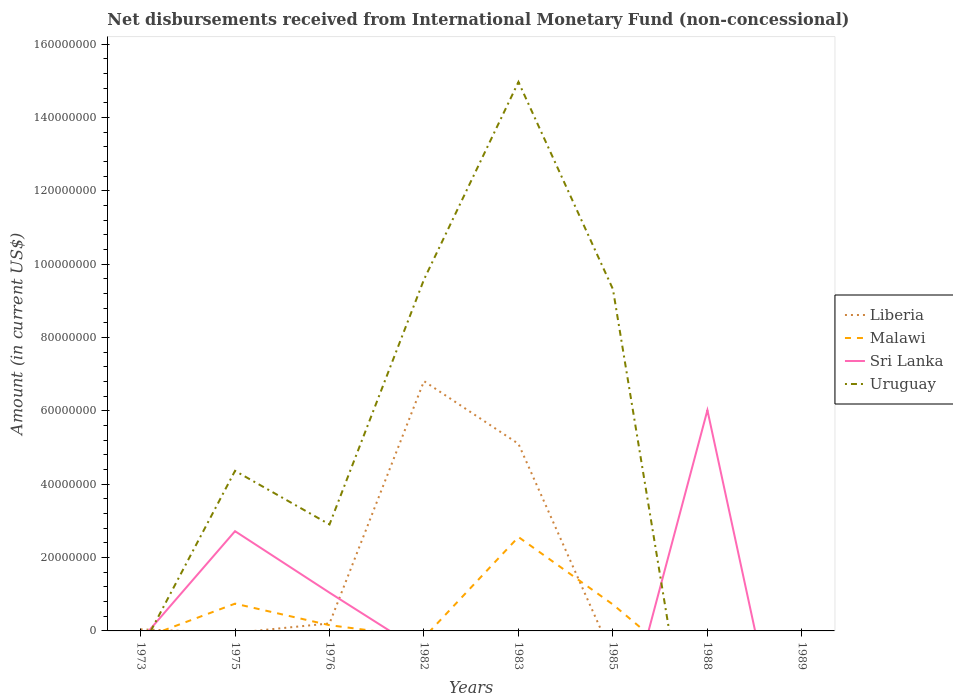Does the line corresponding to Uruguay intersect with the line corresponding to Malawi?
Your answer should be compact. Yes. Across all years, what is the maximum amount of disbursements received from International Monetary Fund in Sri Lanka?
Your response must be concise. 0. What is the total amount of disbursements received from International Monetary Fund in Liberia in the graph?
Ensure brevity in your answer.  -6.77e+07. What is the difference between the highest and the second highest amount of disbursements received from International Monetary Fund in Liberia?
Ensure brevity in your answer.  6.81e+07. What is the difference between the highest and the lowest amount of disbursements received from International Monetary Fund in Uruguay?
Offer a very short reply. 3. How many years are there in the graph?
Offer a very short reply. 8. What is the difference between two consecutive major ticks on the Y-axis?
Make the answer very short. 2.00e+07. Does the graph contain any zero values?
Ensure brevity in your answer.  Yes. Where does the legend appear in the graph?
Ensure brevity in your answer.  Center right. How are the legend labels stacked?
Keep it short and to the point. Vertical. What is the title of the graph?
Your answer should be very brief. Net disbursements received from International Monetary Fund (non-concessional). What is the Amount (in current US$) of Liberia in 1973?
Keep it short and to the point. 4.29e+05. What is the Amount (in current US$) of Malawi in 1973?
Offer a terse response. 0. What is the Amount (in current US$) of Sri Lanka in 1973?
Provide a succinct answer. 0. What is the Amount (in current US$) in Malawi in 1975?
Provide a short and direct response. 7.43e+06. What is the Amount (in current US$) in Sri Lanka in 1975?
Offer a terse response. 2.72e+07. What is the Amount (in current US$) of Uruguay in 1975?
Give a very brief answer. 4.36e+07. What is the Amount (in current US$) in Liberia in 1976?
Offer a very short reply. 2.04e+06. What is the Amount (in current US$) in Malawi in 1976?
Your answer should be very brief. 1.57e+06. What is the Amount (in current US$) of Sri Lanka in 1976?
Give a very brief answer. 1.04e+07. What is the Amount (in current US$) in Uruguay in 1976?
Your answer should be compact. 2.90e+07. What is the Amount (in current US$) in Liberia in 1982?
Your answer should be compact. 6.81e+07. What is the Amount (in current US$) in Malawi in 1982?
Offer a terse response. 0. What is the Amount (in current US$) in Sri Lanka in 1982?
Make the answer very short. 0. What is the Amount (in current US$) of Uruguay in 1982?
Your response must be concise. 9.58e+07. What is the Amount (in current US$) in Liberia in 1983?
Offer a terse response. 5.10e+07. What is the Amount (in current US$) of Malawi in 1983?
Make the answer very short. 2.56e+07. What is the Amount (in current US$) of Uruguay in 1983?
Provide a short and direct response. 1.50e+08. What is the Amount (in current US$) of Liberia in 1985?
Offer a terse response. 0. What is the Amount (in current US$) in Malawi in 1985?
Offer a terse response. 7.20e+06. What is the Amount (in current US$) in Uruguay in 1985?
Your response must be concise. 9.32e+07. What is the Amount (in current US$) in Liberia in 1988?
Give a very brief answer. 0. What is the Amount (in current US$) of Sri Lanka in 1988?
Make the answer very short. 6.02e+07. What is the Amount (in current US$) in Liberia in 1989?
Your response must be concise. 0. What is the Amount (in current US$) in Uruguay in 1989?
Your answer should be compact. 0. Across all years, what is the maximum Amount (in current US$) in Liberia?
Your response must be concise. 6.81e+07. Across all years, what is the maximum Amount (in current US$) of Malawi?
Provide a short and direct response. 2.56e+07. Across all years, what is the maximum Amount (in current US$) in Sri Lanka?
Make the answer very short. 6.02e+07. Across all years, what is the maximum Amount (in current US$) of Uruguay?
Your answer should be very brief. 1.50e+08. Across all years, what is the minimum Amount (in current US$) of Malawi?
Provide a short and direct response. 0. What is the total Amount (in current US$) of Liberia in the graph?
Keep it short and to the point. 1.22e+08. What is the total Amount (in current US$) of Malawi in the graph?
Your response must be concise. 4.18e+07. What is the total Amount (in current US$) in Sri Lanka in the graph?
Offer a terse response. 9.78e+07. What is the total Amount (in current US$) of Uruguay in the graph?
Your answer should be very brief. 4.11e+08. What is the difference between the Amount (in current US$) in Liberia in 1973 and that in 1976?
Your answer should be compact. -1.62e+06. What is the difference between the Amount (in current US$) in Liberia in 1973 and that in 1982?
Your response must be concise. -6.77e+07. What is the difference between the Amount (in current US$) of Liberia in 1973 and that in 1983?
Make the answer very short. -5.06e+07. What is the difference between the Amount (in current US$) in Malawi in 1975 and that in 1976?
Give a very brief answer. 5.86e+06. What is the difference between the Amount (in current US$) in Sri Lanka in 1975 and that in 1976?
Keep it short and to the point. 1.68e+07. What is the difference between the Amount (in current US$) in Uruguay in 1975 and that in 1976?
Your answer should be compact. 1.46e+07. What is the difference between the Amount (in current US$) in Uruguay in 1975 and that in 1982?
Give a very brief answer. -5.22e+07. What is the difference between the Amount (in current US$) of Malawi in 1975 and that in 1983?
Your answer should be very brief. -1.82e+07. What is the difference between the Amount (in current US$) of Uruguay in 1975 and that in 1983?
Ensure brevity in your answer.  -1.06e+08. What is the difference between the Amount (in current US$) in Malawi in 1975 and that in 1985?
Your answer should be very brief. 2.33e+05. What is the difference between the Amount (in current US$) of Uruguay in 1975 and that in 1985?
Make the answer very short. -4.95e+07. What is the difference between the Amount (in current US$) in Sri Lanka in 1975 and that in 1988?
Provide a succinct answer. -3.30e+07. What is the difference between the Amount (in current US$) in Liberia in 1976 and that in 1982?
Your answer should be compact. -6.61e+07. What is the difference between the Amount (in current US$) in Uruguay in 1976 and that in 1982?
Your response must be concise. -6.68e+07. What is the difference between the Amount (in current US$) of Liberia in 1976 and that in 1983?
Offer a terse response. -4.90e+07. What is the difference between the Amount (in current US$) of Malawi in 1976 and that in 1983?
Provide a succinct answer. -2.40e+07. What is the difference between the Amount (in current US$) in Uruguay in 1976 and that in 1983?
Provide a short and direct response. -1.21e+08. What is the difference between the Amount (in current US$) in Malawi in 1976 and that in 1985?
Your answer should be compact. -5.63e+06. What is the difference between the Amount (in current US$) of Uruguay in 1976 and that in 1985?
Provide a short and direct response. -6.41e+07. What is the difference between the Amount (in current US$) of Sri Lanka in 1976 and that in 1988?
Offer a very short reply. -4.97e+07. What is the difference between the Amount (in current US$) of Liberia in 1982 and that in 1983?
Offer a terse response. 1.71e+07. What is the difference between the Amount (in current US$) of Uruguay in 1982 and that in 1983?
Give a very brief answer. -5.39e+07. What is the difference between the Amount (in current US$) of Uruguay in 1982 and that in 1985?
Your answer should be compact. 2.64e+06. What is the difference between the Amount (in current US$) in Malawi in 1983 and that in 1985?
Provide a short and direct response. 1.84e+07. What is the difference between the Amount (in current US$) of Uruguay in 1983 and that in 1985?
Provide a short and direct response. 5.65e+07. What is the difference between the Amount (in current US$) in Liberia in 1973 and the Amount (in current US$) in Malawi in 1975?
Your answer should be compact. -7.00e+06. What is the difference between the Amount (in current US$) in Liberia in 1973 and the Amount (in current US$) in Sri Lanka in 1975?
Give a very brief answer. -2.68e+07. What is the difference between the Amount (in current US$) in Liberia in 1973 and the Amount (in current US$) in Uruguay in 1975?
Ensure brevity in your answer.  -4.32e+07. What is the difference between the Amount (in current US$) in Liberia in 1973 and the Amount (in current US$) in Malawi in 1976?
Give a very brief answer. -1.14e+06. What is the difference between the Amount (in current US$) in Liberia in 1973 and the Amount (in current US$) in Sri Lanka in 1976?
Provide a short and direct response. -1.00e+07. What is the difference between the Amount (in current US$) in Liberia in 1973 and the Amount (in current US$) in Uruguay in 1976?
Offer a terse response. -2.86e+07. What is the difference between the Amount (in current US$) in Liberia in 1973 and the Amount (in current US$) in Uruguay in 1982?
Ensure brevity in your answer.  -9.54e+07. What is the difference between the Amount (in current US$) in Liberia in 1973 and the Amount (in current US$) in Malawi in 1983?
Offer a very short reply. -2.52e+07. What is the difference between the Amount (in current US$) in Liberia in 1973 and the Amount (in current US$) in Uruguay in 1983?
Provide a succinct answer. -1.49e+08. What is the difference between the Amount (in current US$) in Liberia in 1973 and the Amount (in current US$) in Malawi in 1985?
Offer a terse response. -6.77e+06. What is the difference between the Amount (in current US$) of Liberia in 1973 and the Amount (in current US$) of Uruguay in 1985?
Provide a succinct answer. -9.27e+07. What is the difference between the Amount (in current US$) of Liberia in 1973 and the Amount (in current US$) of Sri Lanka in 1988?
Give a very brief answer. -5.97e+07. What is the difference between the Amount (in current US$) of Malawi in 1975 and the Amount (in current US$) of Sri Lanka in 1976?
Your answer should be compact. -3.00e+06. What is the difference between the Amount (in current US$) of Malawi in 1975 and the Amount (in current US$) of Uruguay in 1976?
Your answer should be very brief. -2.16e+07. What is the difference between the Amount (in current US$) in Sri Lanka in 1975 and the Amount (in current US$) in Uruguay in 1976?
Ensure brevity in your answer.  -1.83e+06. What is the difference between the Amount (in current US$) in Malawi in 1975 and the Amount (in current US$) in Uruguay in 1982?
Give a very brief answer. -8.84e+07. What is the difference between the Amount (in current US$) in Sri Lanka in 1975 and the Amount (in current US$) in Uruguay in 1982?
Give a very brief answer. -6.86e+07. What is the difference between the Amount (in current US$) of Malawi in 1975 and the Amount (in current US$) of Uruguay in 1983?
Ensure brevity in your answer.  -1.42e+08. What is the difference between the Amount (in current US$) in Sri Lanka in 1975 and the Amount (in current US$) in Uruguay in 1983?
Give a very brief answer. -1.22e+08. What is the difference between the Amount (in current US$) in Malawi in 1975 and the Amount (in current US$) in Uruguay in 1985?
Your response must be concise. -8.57e+07. What is the difference between the Amount (in current US$) in Sri Lanka in 1975 and the Amount (in current US$) in Uruguay in 1985?
Your answer should be compact. -6.60e+07. What is the difference between the Amount (in current US$) in Malawi in 1975 and the Amount (in current US$) in Sri Lanka in 1988?
Give a very brief answer. -5.27e+07. What is the difference between the Amount (in current US$) of Liberia in 1976 and the Amount (in current US$) of Uruguay in 1982?
Provide a short and direct response. -9.38e+07. What is the difference between the Amount (in current US$) in Malawi in 1976 and the Amount (in current US$) in Uruguay in 1982?
Make the answer very short. -9.42e+07. What is the difference between the Amount (in current US$) of Sri Lanka in 1976 and the Amount (in current US$) of Uruguay in 1982?
Provide a succinct answer. -8.54e+07. What is the difference between the Amount (in current US$) in Liberia in 1976 and the Amount (in current US$) in Malawi in 1983?
Offer a very short reply. -2.36e+07. What is the difference between the Amount (in current US$) of Liberia in 1976 and the Amount (in current US$) of Uruguay in 1983?
Provide a short and direct response. -1.48e+08. What is the difference between the Amount (in current US$) of Malawi in 1976 and the Amount (in current US$) of Uruguay in 1983?
Your answer should be compact. -1.48e+08. What is the difference between the Amount (in current US$) of Sri Lanka in 1976 and the Amount (in current US$) of Uruguay in 1983?
Ensure brevity in your answer.  -1.39e+08. What is the difference between the Amount (in current US$) of Liberia in 1976 and the Amount (in current US$) of Malawi in 1985?
Give a very brief answer. -5.16e+06. What is the difference between the Amount (in current US$) of Liberia in 1976 and the Amount (in current US$) of Uruguay in 1985?
Give a very brief answer. -9.11e+07. What is the difference between the Amount (in current US$) in Malawi in 1976 and the Amount (in current US$) in Uruguay in 1985?
Provide a short and direct response. -9.16e+07. What is the difference between the Amount (in current US$) in Sri Lanka in 1976 and the Amount (in current US$) in Uruguay in 1985?
Provide a short and direct response. -8.27e+07. What is the difference between the Amount (in current US$) in Liberia in 1976 and the Amount (in current US$) in Sri Lanka in 1988?
Your answer should be compact. -5.81e+07. What is the difference between the Amount (in current US$) in Malawi in 1976 and the Amount (in current US$) in Sri Lanka in 1988?
Keep it short and to the point. -5.86e+07. What is the difference between the Amount (in current US$) of Liberia in 1982 and the Amount (in current US$) of Malawi in 1983?
Provide a short and direct response. 4.25e+07. What is the difference between the Amount (in current US$) in Liberia in 1982 and the Amount (in current US$) in Uruguay in 1983?
Offer a terse response. -8.16e+07. What is the difference between the Amount (in current US$) of Liberia in 1982 and the Amount (in current US$) of Malawi in 1985?
Provide a short and direct response. 6.09e+07. What is the difference between the Amount (in current US$) in Liberia in 1982 and the Amount (in current US$) in Uruguay in 1985?
Give a very brief answer. -2.51e+07. What is the difference between the Amount (in current US$) of Liberia in 1982 and the Amount (in current US$) of Sri Lanka in 1988?
Offer a terse response. 7.93e+06. What is the difference between the Amount (in current US$) in Liberia in 1983 and the Amount (in current US$) in Malawi in 1985?
Offer a very short reply. 4.38e+07. What is the difference between the Amount (in current US$) of Liberia in 1983 and the Amount (in current US$) of Uruguay in 1985?
Provide a short and direct response. -4.22e+07. What is the difference between the Amount (in current US$) of Malawi in 1983 and the Amount (in current US$) of Uruguay in 1985?
Offer a terse response. -6.76e+07. What is the difference between the Amount (in current US$) of Liberia in 1983 and the Amount (in current US$) of Sri Lanka in 1988?
Provide a short and direct response. -9.17e+06. What is the difference between the Amount (in current US$) in Malawi in 1983 and the Amount (in current US$) in Sri Lanka in 1988?
Ensure brevity in your answer.  -3.46e+07. What is the difference between the Amount (in current US$) of Malawi in 1985 and the Amount (in current US$) of Sri Lanka in 1988?
Offer a very short reply. -5.30e+07. What is the average Amount (in current US$) of Liberia per year?
Make the answer very short. 1.52e+07. What is the average Amount (in current US$) of Malawi per year?
Your response must be concise. 5.23e+06. What is the average Amount (in current US$) in Sri Lanka per year?
Provide a succinct answer. 1.22e+07. What is the average Amount (in current US$) in Uruguay per year?
Give a very brief answer. 5.14e+07. In the year 1975, what is the difference between the Amount (in current US$) in Malawi and Amount (in current US$) in Sri Lanka?
Make the answer very short. -1.98e+07. In the year 1975, what is the difference between the Amount (in current US$) of Malawi and Amount (in current US$) of Uruguay?
Offer a very short reply. -3.62e+07. In the year 1975, what is the difference between the Amount (in current US$) in Sri Lanka and Amount (in current US$) in Uruguay?
Your answer should be very brief. -1.64e+07. In the year 1976, what is the difference between the Amount (in current US$) of Liberia and Amount (in current US$) of Malawi?
Ensure brevity in your answer.  4.74e+05. In the year 1976, what is the difference between the Amount (in current US$) in Liberia and Amount (in current US$) in Sri Lanka?
Give a very brief answer. -8.39e+06. In the year 1976, what is the difference between the Amount (in current US$) of Liberia and Amount (in current US$) of Uruguay?
Give a very brief answer. -2.70e+07. In the year 1976, what is the difference between the Amount (in current US$) in Malawi and Amount (in current US$) in Sri Lanka?
Your answer should be very brief. -8.86e+06. In the year 1976, what is the difference between the Amount (in current US$) in Malawi and Amount (in current US$) in Uruguay?
Provide a succinct answer. -2.75e+07. In the year 1976, what is the difference between the Amount (in current US$) in Sri Lanka and Amount (in current US$) in Uruguay?
Keep it short and to the point. -1.86e+07. In the year 1982, what is the difference between the Amount (in current US$) in Liberia and Amount (in current US$) in Uruguay?
Your answer should be very brief. -2.77e+07. In the year 1983, what is the difference between the Amount (in current US$) of Liberia and Amount (in current US$) of Malawi?
Make the answer very short. 2.54e+07. In the year 1983, what is the difference between the Amount (in current US$) in Liberia and Amount (in current US$) in Uruguay?
Keep it short and to the point. -9.87e+07. In the year 1983, what is the difference between the Amount (in current US$) in Malawi and Amount (in current US$) in Uruguay?
Give a very brief answer. -1.24e+08. In the year 1985, what is the difference between the Amount (in current US$) in Malawi and Amount (in current US$) in Uruguay?
Provide a succinct answer. -8.60e+07. What is the ratio of the Amount (in current US$) of Liberia in 1973 to that in 1976?
Offer a terse response. 0.21. What is the ratio of the Amount (in current US$) of Liberia in 1973 to that in 1982?
Provide a succinct answer. 0.01. What is the ratio of the Amount (in current US$) in Liberia in 1973 to that in 1983?
Give a very brief answer. 0.01. What is the ratio of the Amount (in current US$) of Malawi in 1975 to that in 1976?
Your response must be concise. 4.73. What is the ratio of the Amount (in current US$) in Sri Lanka in 1975 to that in 1976?
Offer a very short reply. 2.61. What is the ratio of the Amount (in current US$) in Uruguay in 1975 to that in 1976?
Offer a very short reply. 1.5. What is the ratio of the Amount (in current US$) of Uruguay in 1975 to that in 1982?
Provide a succinct answer. 0.46. What is the ratio of the Amount (in current US$) in Malawi in 1975 to that in 1983?
Keep it short and to the point. 0.29. What is the ratio of the Amount (in current US$) of Uruguay in 1975 to that in 1983?
Your answer should be very brief. 0.29. What is the ratio of the Amount (in current US$) of Malawi in 1975 to that in 1985?
Provide a succinct answer. 1.03. What is the ratio of the Amount (in current US$) of Uruguay in 1975 to that in 1985?
Keep it short and to the point. 0.47. What is the ratio of the Amount (in current US$) in Sri Lanka in 1975 to that in 1988?
Your answer should be very brief. 0.45. What is the ratio of the Amount (in current US$) in Uruguay in 1976 to that in 1982?
Your answer should be compact. 0.3. What is the ratio of the Amount (in current US$) of Liberia in 1976 to that in 1983?
Provide a short and direct response. 0.04. What is the ratio of the Amount (in current US$) of Malawi in 1976 to that in 1983?
Keep it short and to the point. 0.06. What is the ratio of the Amount (in current US$) of Uruguay in 1976 to that in 1983?
Your answer should be compact. 0.19. What is the ratio of the Amount (in current US$) in Malawi in 1976 to that in 1985?
Your answer should be compact. 0.22. What is the ratio of the Amount (in current US$) in Uruguay in 1976 to that in 1985?
Provide a succinct answer. 0.31. What is the ratio of the Amount (in current US$) in Sri Lanka in 1976 to that in 1988?
Your answer should be very brief. 0.17. What is the ratio of the Amount (in current US$) in Liberia in 1982 to that in 1983?
Offer a very short reply. 1.34. What is the ratio of the Amount (in current US$) in Uruguay in 1982 to that in 1983?
Offer a terse response. 0.64. What is the ratio of the Amount (in current US$) in Uruguay in 1982 to that in 1985?
Ensure brevity in your answer.  1.03. What is the ratio of the Amount (in current US$) in Malawi in 1983 to that in 1985?
Make the answer very short. 3.56. What is the ratio of the Amount (in current US$) in Uruguay in 1983 to that in 1985?
Offer a terse response. 1.61. What is the difference between the highest and the second highest Amount (in current US$) in Liberia?
Keep it short and to the point. 1.71e+07. What is the difference between the highest and the second highest Amount (in current US$) of Malawi?
Ensure brevity in your answer.  1.82e+07. What is the difference between the highest and the second highest Amount (in current US$) of Sri Lanka?
Your answer should be very brief. 3.30e+07. What is the difference between the highest and the second highest Amount (in current US$) of Uruguay?
Your answer should be compact. 5.39e+07. What is the difference between the highest and the lowest Amount (in current US$) of Liberia?
Ensure brevity in your answer.  6.81e+07. What is the difference between the highest and the lowest Amount (in current US$) in Malawi?
Make the answer very short. 2.56e+07. What is the difference between the highest and the lowest Amount (in current US$) in Sri Lanka?
Give a very brief answer. 6.02e+07. What is the difference between the highest and the lowest Amount (in current US$) of Uruguay?
Offer a terse response. 1.50e+08. 